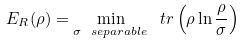Convert formula to latex. <formula><loc_0><loc_0><loc_500><loc_500>E _ { R } ( \rho ) = \min _ { \sigma \ s e p a r a b l e } \ t r \left ( \rho \ln \frac { \rho } { \sigma } \right )</formula> 